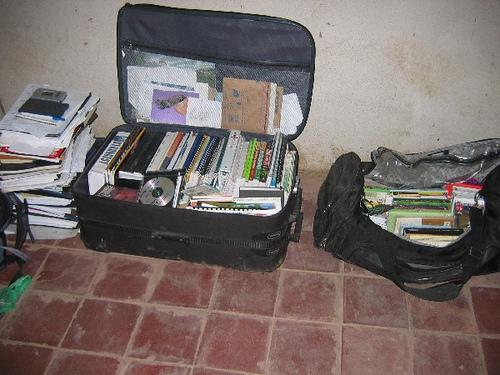What is the color of the pen and its cap? Where is it located? The pen is white with a blue cap and is found on top of papers. Imagine an advertisement for the black duffle bag. Describe its features and uses. Introducing the versatile black duffle bag, capable of holding all your essentials! With a sturdy pull handle, convenient zippered pouch, and spacious interior for storing items like books, it's perfect for travel, school or everyday use. Mention three objects found inside the opened black bag and their positions. Inside the black bag, there are numerous books, a CD case, and various papers. Is there a suitcase in the image? Describe its contents and location. Yes, there is a black suitcase in the image. It's open on the floor, and it's filled with many items, including a row of books. Select and describe one element of the surroundings in the image. The floor is red square tile flooring, covered with dust and dirt. List three objects found on the floor besides the black suitcase and duffle bag. A stack of books, headphones sitting on the floor, and a pile of papers. What type of bag is on the floor, and what is inside it? There is a black duffle bag on the floor, and it is filled with books. What color and material is the floor made of, and what condition is it in? The floor is made of red tiles in a square pattern, and it's dusty and dirty. 